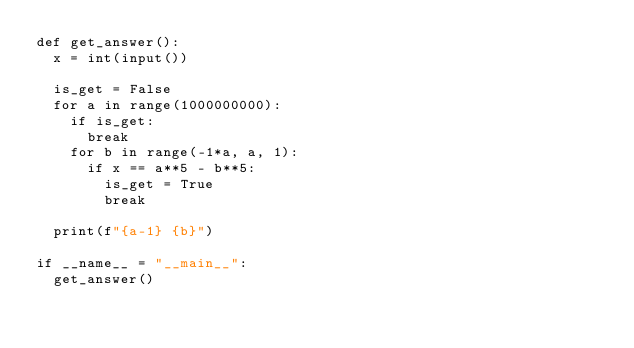Convert code to text. <code><loc_0><loc_0><loc_500><loc_500><_Python_>def get_answer():
  x = int(input())
  
  is_get = False
  for a in range(1000000000):
    if is_get:
      break
    for b in range(-1*a, a, 1):
      if x == a**5 - b**5:
        is_get = True
        break
        
  print(f"{a-1} {b}")

if __name__ = "__main__":
  get_answer()</code> 